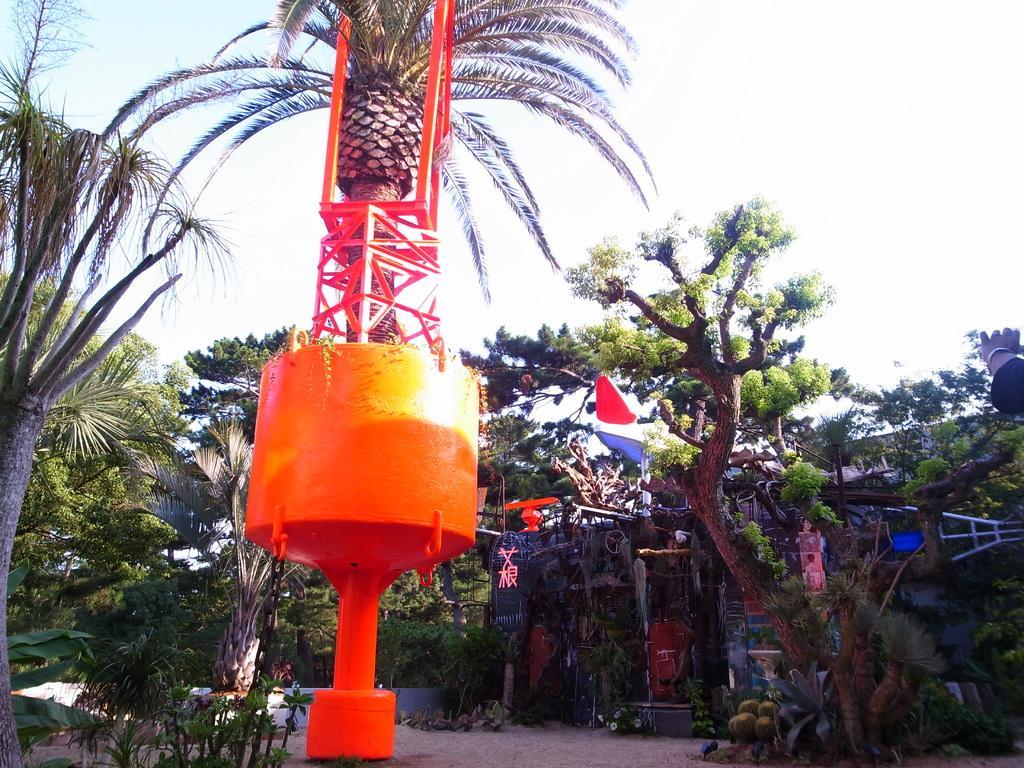Could you give a brief overview of what you see in this image? In the foreground of the picture there are plants, trees and a construction. In the background there are trees, boards and other objects. On the right there is a person's hand. Sky is sunny. 